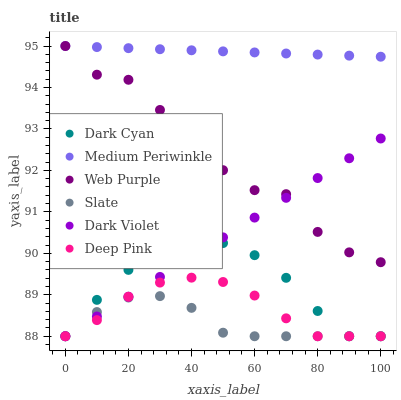Does Slate have the minimum area under the curve?
Answer yes or no. Yes. Does Medium Periwinkle have the maximum area under the curve?
Answer yes or no. Yes. Does Medium Periwinkle have the minimum area under the curve?
Answer yes or no. No. Does Slate have the maximum area under the curve?
Answer yes or no. No. Is Dark Violet the smoothest?
Answer yes or no. Yes. Is Web Purple the roughest?
Answer yes or no. Yes. Is Slate the smoothest?
Answer yes or no. No. Is Slate the roughest?
Answer yes or no. No. Does Deep Pink have the lowest value?
Answer yes or no. Yes. Does Medium Periwinkle have the lowest value?
Answer yes or no. No. Does Web Purple have the highest value?
Answer yes or no. Yes. Does Slate have the highest value?
Answer yes or no. No. Is Dark Cyan less than Web Purple?
Answer yes or no. Yes. Is Medium Periwinkle greater than Slate?
Answer yes or no. Yes. Does Deep Pink intersect Dark Cyan?
Answer yes or no. Yes. Is Deep Pink less than Dark Cyan?
Answer yes or no. No. Is Deep Pink greater than Dark Cyan?
Answer yes or no. No. Does Dark Cyan intersect Web Purple?
Answer yes or no. No. 